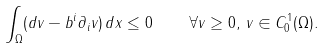Convert formula to latex. <formula><loc_0><loc_0><loc_500><loc_500>\int _ { \Omega } ( d v - b ^ { i } \partial _ { i } v ) \, d x \leq 0 \quad \forall v \geq 0 , \, v \in C ^ { 1 } _ { 0 } ( \Omega ) .</formula> 